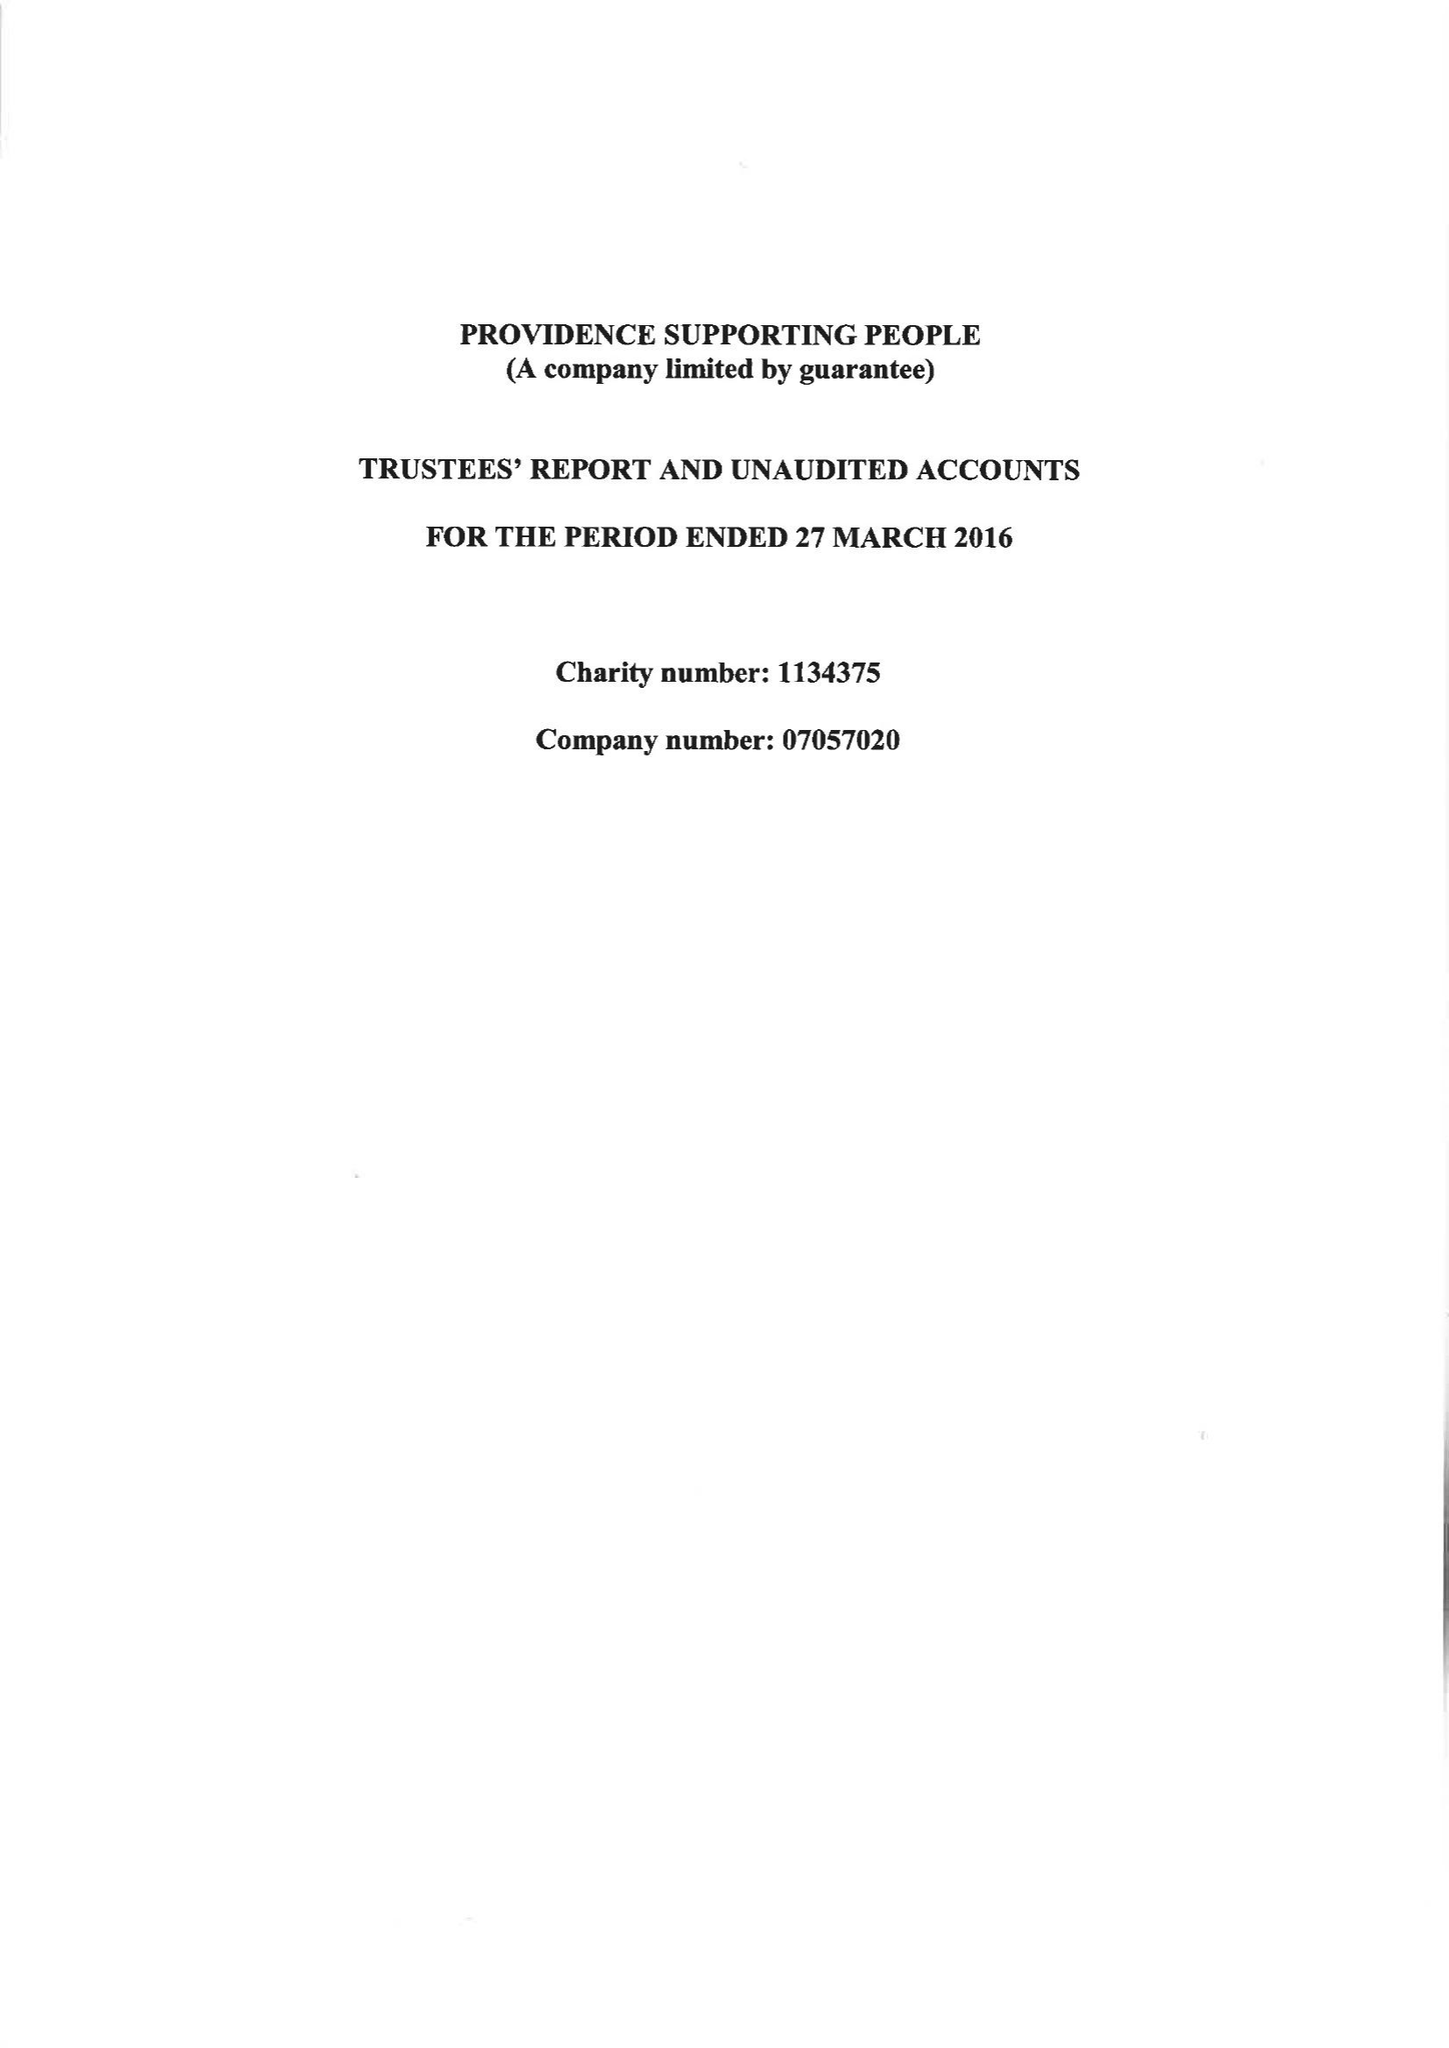What is the value for the charity_number?
Answer the question using a single word or phrase. 1134375 